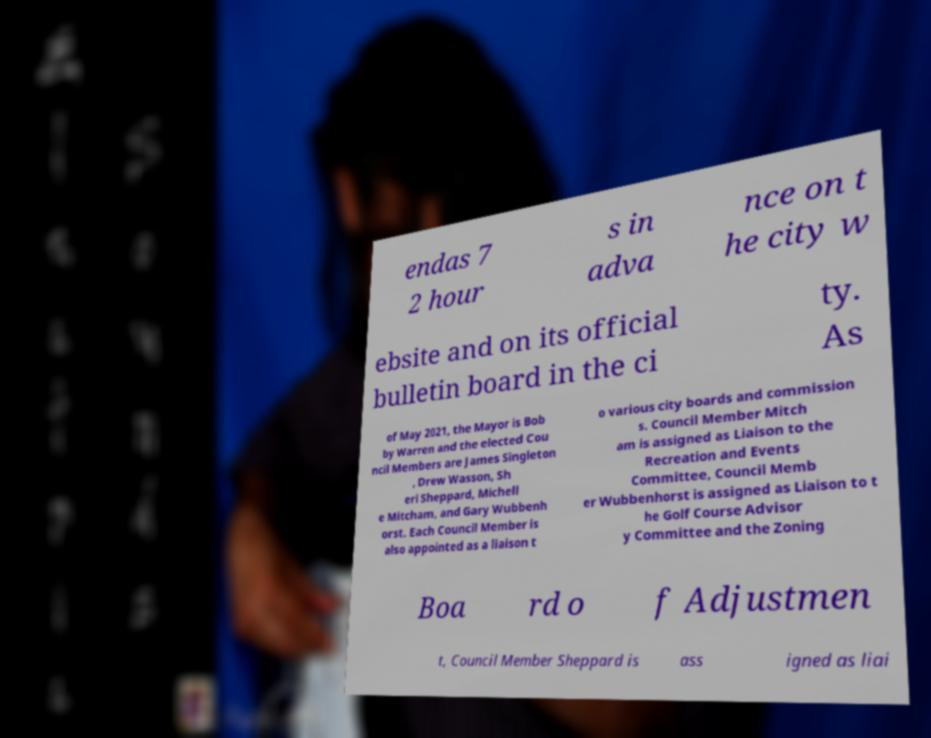Can you read and provide the text displayed in the image?This photo seems to have some interesting text. Can you extract and type it out for me? endas 7 2 hour s in adva nce on t he city w ebsite and on its official bulletin board in the ci ty. As of May 2021, the Mayor is Bob by Warren and the elected Cou ncil Members are James Singleton , Drew Wasson, Sh eri Sheppard, Michell e Mitcham, and Gary Wubbenh orst. Each Council Member is also appointed as a liaison t o various city boards and commission s. Council Member Mitch am is assigned as Liaison to the Recreation and Events Committee, Council Memb er Wubbenhorst is assigned as Liaison to t he Golf Course Advisor y Committee and the Zoning Boa rd o f Adjustmen t, Council Member Sheppard is ass igned as liai 